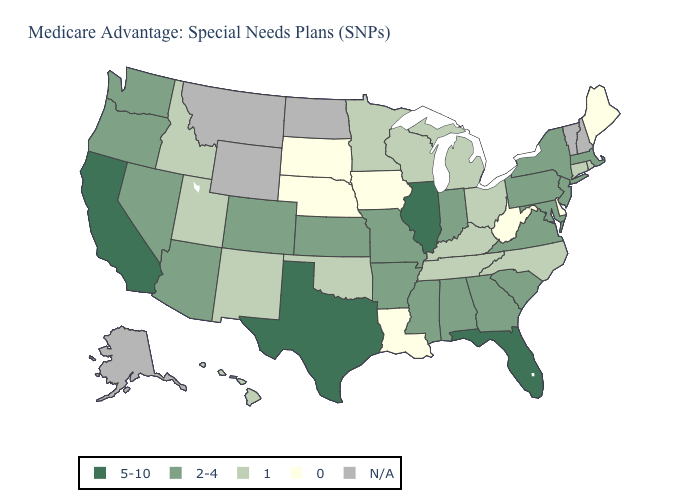What is the value of Indiana?
Quick response, please. 2-4. Name the states that have a value in the range 0?
Give a very brief answer. Delaware, Iowa, Louisiana, Maine, Nebraska, South Dakota, West Virginia. Does the map have missing data?
Quick response, please. Yes. Name the states that have a value in the range 5-10?
Give a very brief answer. California, Florida, Illinois, Texas. Which states have the highest value in the USA?
Answer briefly. California, Florida, Illinois, Texas. Does the map have missing data?
Concise answer only. Yes. Name the states that have a value in the range 2-4?
Give a very brief answer. Alabama, Arkansas, Arizona, Colorado, Georgia, Indiana, Kansas, Massachusetts, Maryland, Missouri, Mississippi, New Jersey, Nevada, New York, Oregon, Pennsylvania, South Carolina, Virginia, Washington. What is the lowest value in the USA?
Give a very brief answer. 0. Among the states that border Nevada , does California have the highest value?
Write a very short answer. Yes. Is the legend a continuous bar?
Be succinct. No. What is the highest value in the USA?
Short answer required. 5-10. Name the states that have a value in the range 5-10?
Quick response, please. California, Florida, Illinois, Texas. Name the states that have a value in the range N/A?
Give a very brief answer. Alaska, Montana, North Dakota, New Hampshire, Vermont, Wyoming. 